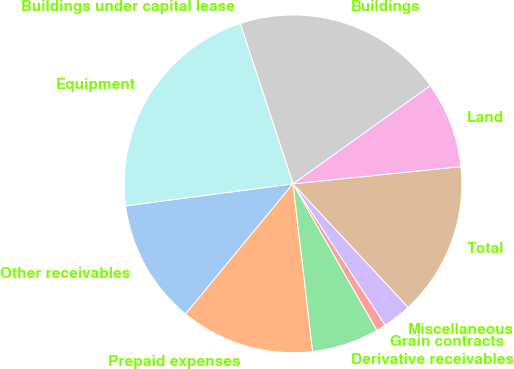<chart> <loc_0><loc_0><loc_500><loc_500><pie_chart><fcel>Other receivables<fcel>Prepaid expenses<fcel>Derivative receivables<fcel>Grain contracts<fcel>Miscellaneous<fcel>Total<fcel>Land<fcel>Buildings<fcel>Buildings under capital lease<fcel>Equipment<nl><fcel>11.93%<fcel>12.84%<fcel>6.42%<fcel>0.92%<fcel>2.75%<fcel>14.68%<fcel>8.26%<fcel>20.18%<fcel>0.0%<fcel>22.02%<nl></chart> 